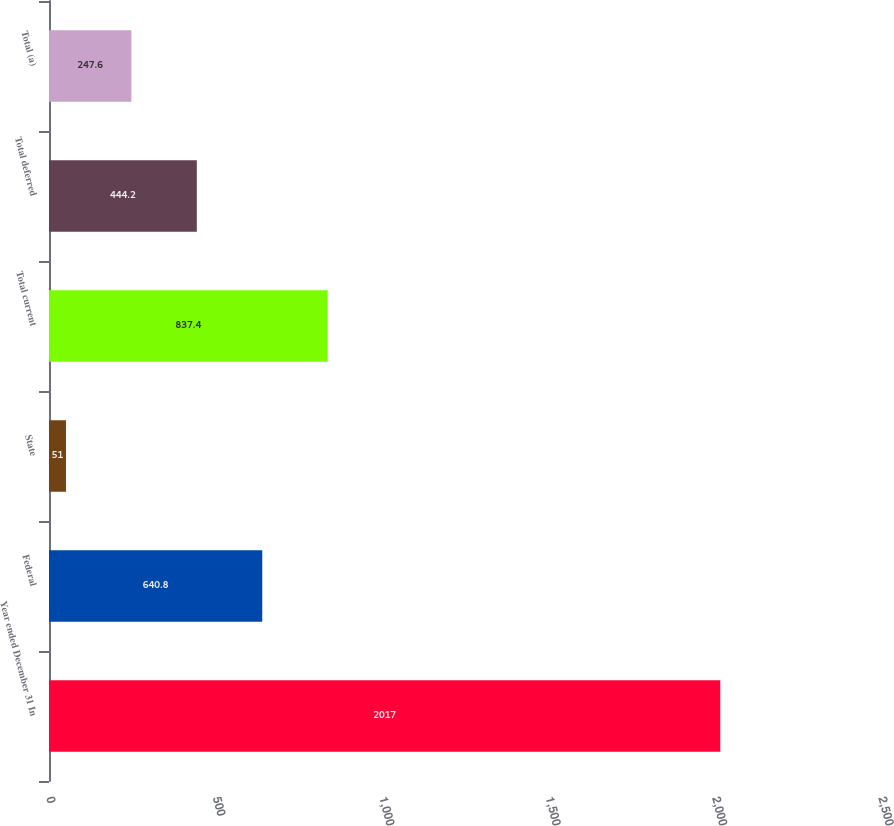<chart> <loc_0><loc_0><loc_500><loc_500><bar_chart><fcel>Year ended December 31 In<fcel>Federal<fcel>State<fcel>Total current<fcel>Total deferred<fcel>Total (a)<nl><fcel>2017<fcel>640.8<fcel>51<fcel>837.4<fcel>444.2<fcel>247.6<nl></chart> 